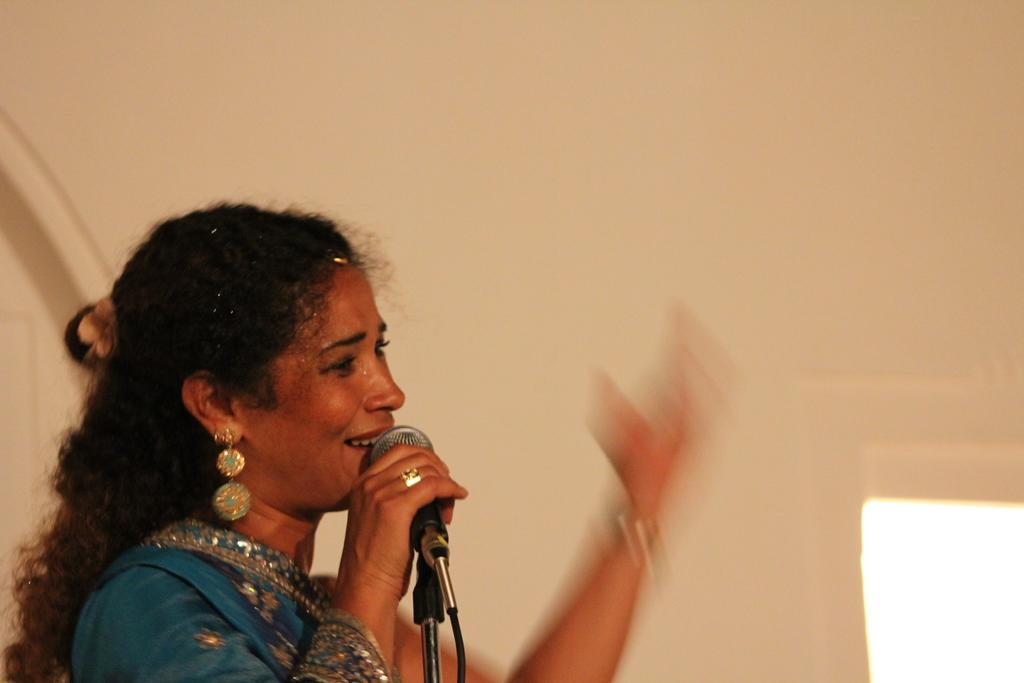Who is the main subject in the image? There is a woman in the image. What is the woman wearing? The woman is wearing a dress. What is the woman holding in her hand? The woman is holding a microphone in her hand. How is the microphone positioned in the image? The microphone is placed on a stand. What type of observation can be made by the doctor in the image? There is no doctor present in the image, so no observation can be made by a doctor. 